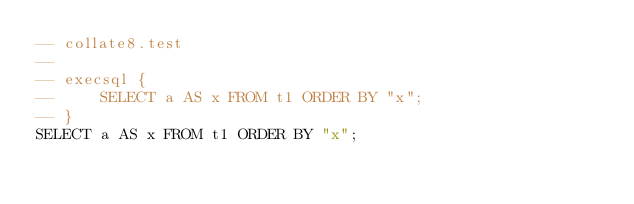<code> <loc_0><loc_0><loc_500><loc_500><_SQL_>-- collate8.test
-- 
-- execsql {
--     SELECT a AS x FROM t1 ORDER BY "x";
-- }
SELECT a AS x FROM t1 ORDER BY "x";</code> 